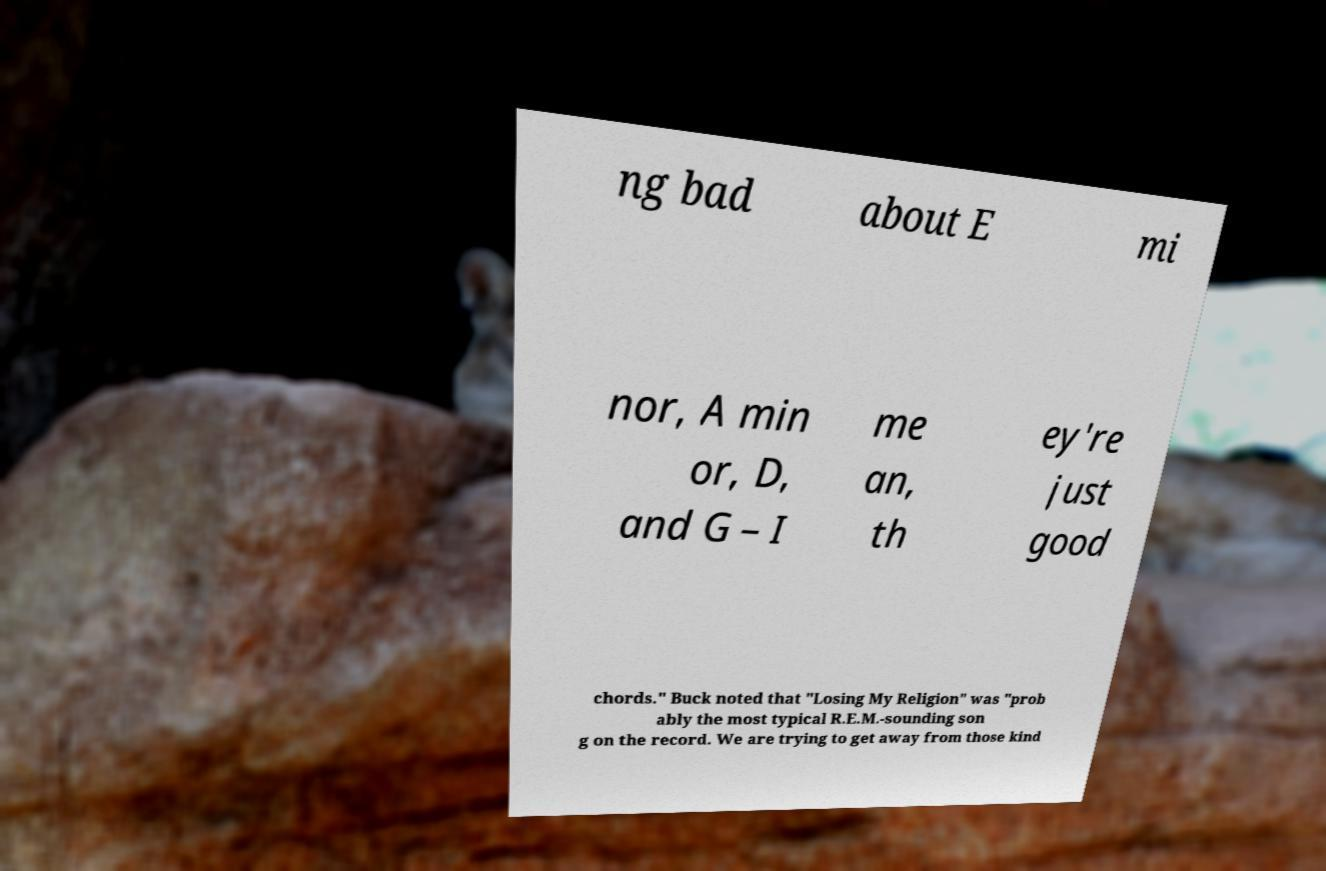There's text embedded in this image that I need extracted. Can you transcribe it verbatim? ng bad about E mi nor, A min or, D, and G – I me an, th ey're just good chords." Buck noted that "Losing My Religion" was "prob ably the most typical R.E.M.-sounding son g on the record. We are trying to get away from those kind 